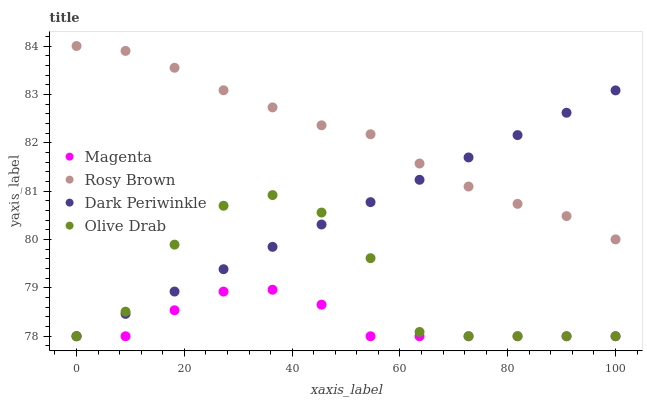Does Magenta have the minimum area under the curve?
Answer yes or no. Yes. Does Rosy Brown have the maximum area under the curve?
Answer yes or no. Yes. Does Dark Periwinkle have the minimum area under the curve?
Answer yes or no. No. Does Dark Periwinkle have the maximum area under the curve?
Answer yes or no. No. Is Dark Periwinkle the smoothest?
Answer yes or no. Yes. Is Olive Drab the roughest?
Answer yes or no. Yes. Is Rosy Brown the smoothest?
Answer yes or no. No. Is Rosy Brown the roughest?
Answer yes or no. No. Does Magenta have the lowest value?
Answer yes or no. Yes. Does Rosy Brown have the lowest value?
Answer yes or no. No. Does Rosy Brown have the highest value?
Answer yes or no. Yes. Does Dark Periwinkle have the highest value?
Answer yes or no. No. Is Olive Drab less than Rosy Brown?
Answer yes or no. Yes. Is Rosy Brown greater than Olive Drab?
Answer yes or no. Yes. Does Magenta intersect Dark Periwinkle?
Answer yes or no. Yes. Is Magenta less than Dark Periwinkle?
Answer yes or no. No. Is Magenta greater than Dark Periwinkle?
Answer yes or no. No. Does Olive Drab intersect Rosy Brown?
Answer yes or no. No. 